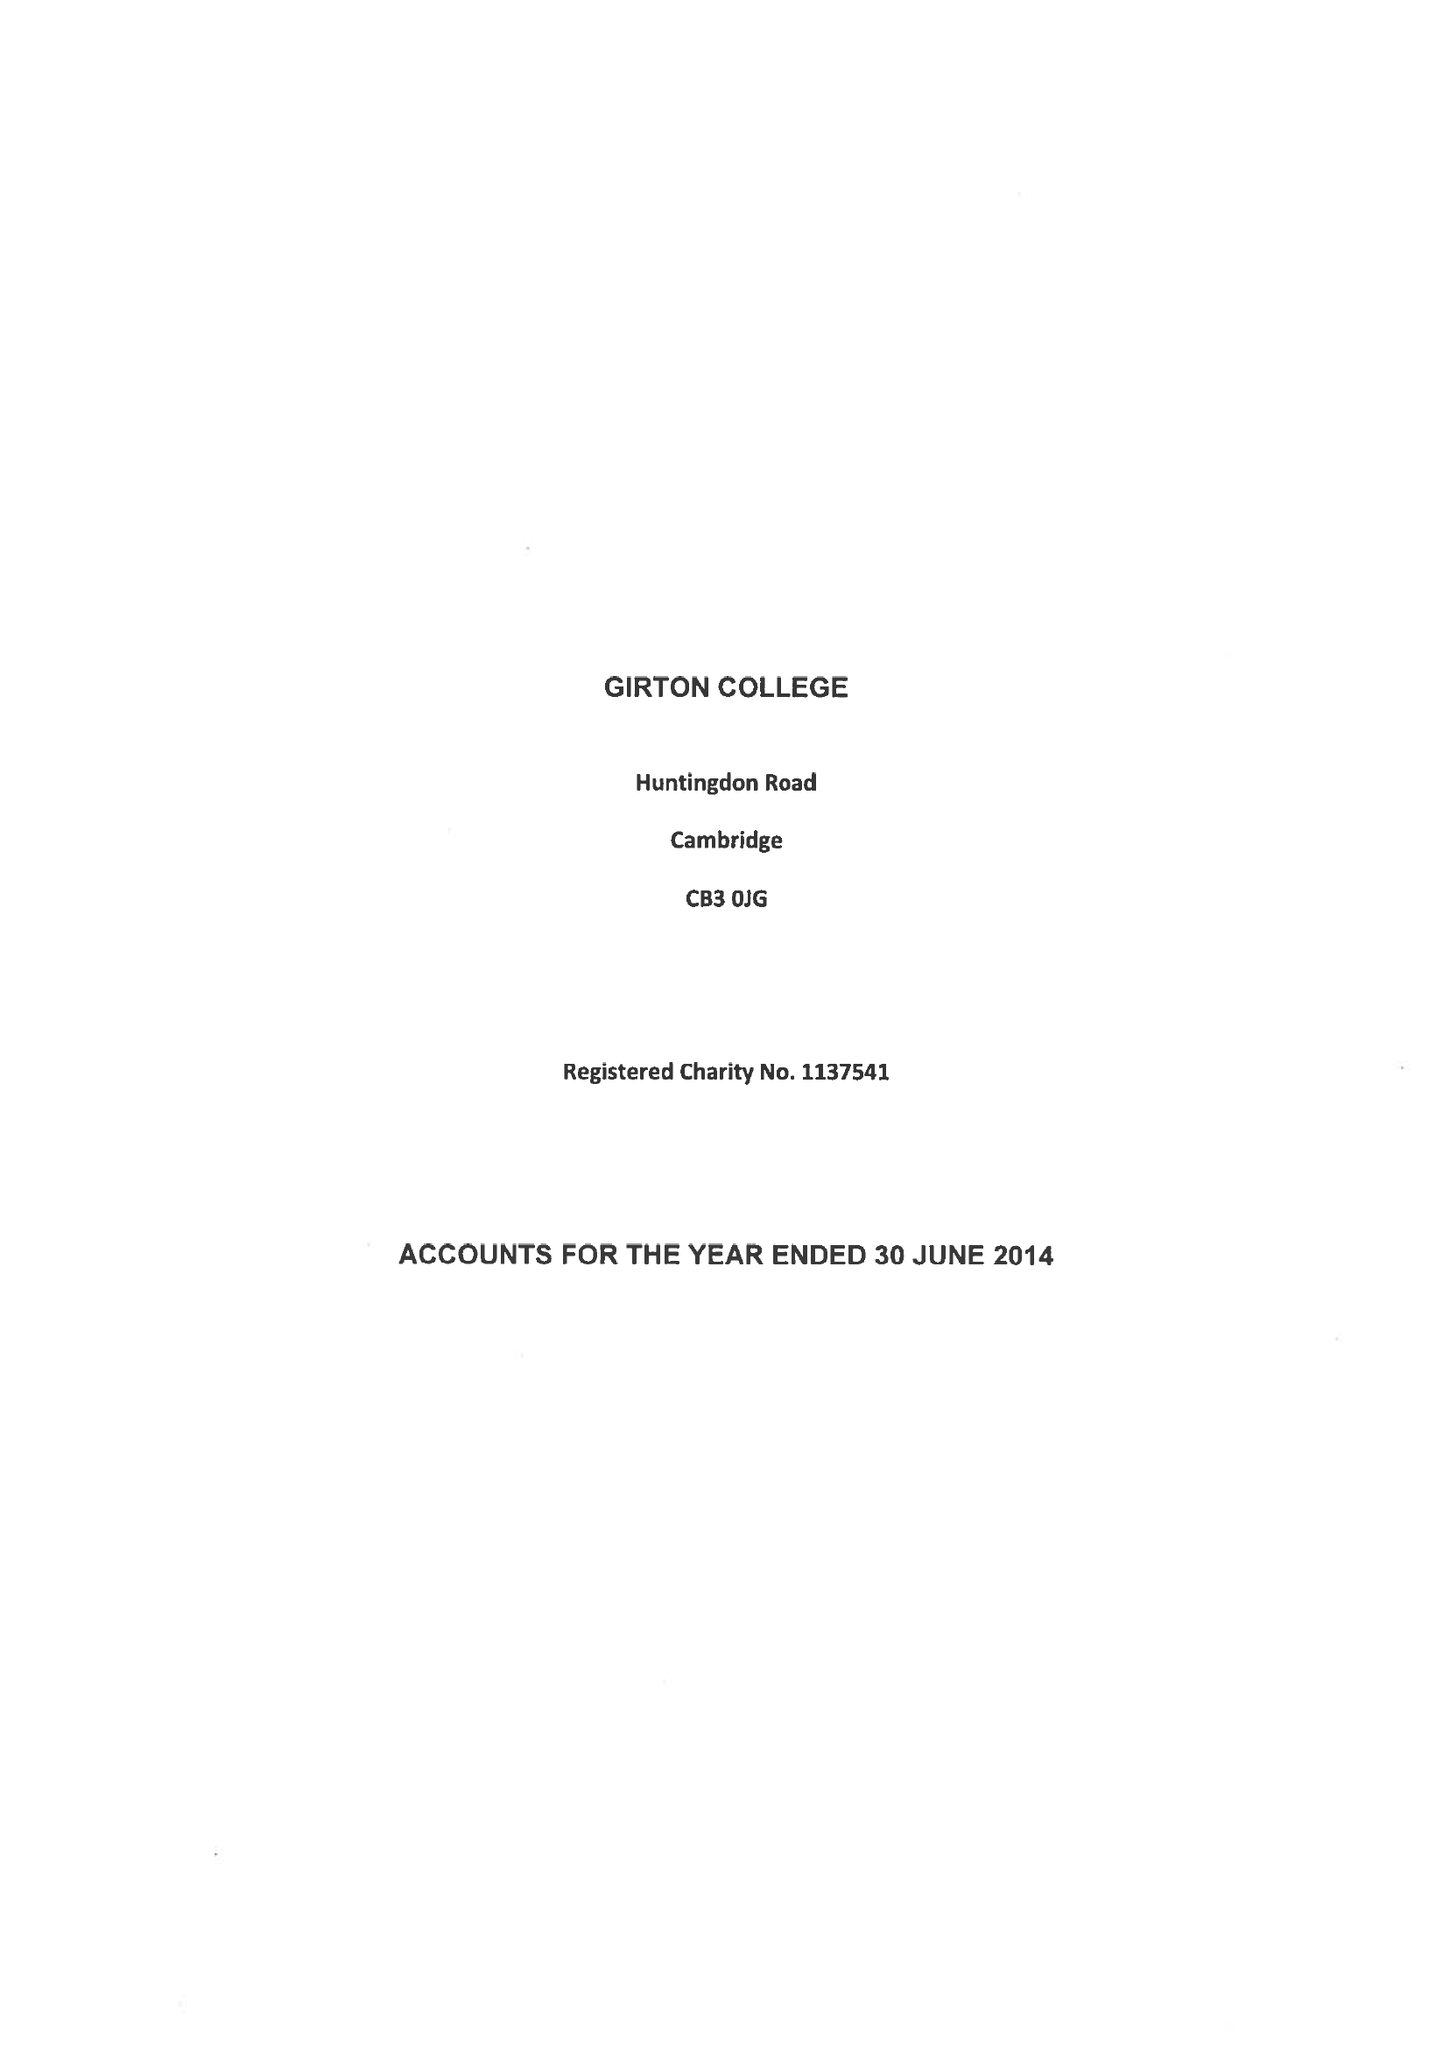What is the value for the charity_number?
Answer the question using a single word or phrase. 1137541 